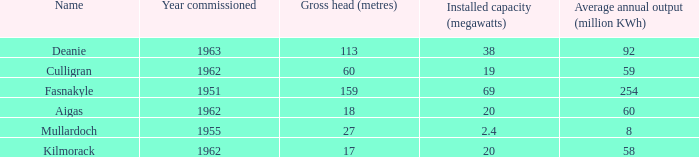What is the Year Commissioned of the power stationo with a Gross head of less than 18? 1962.0. 